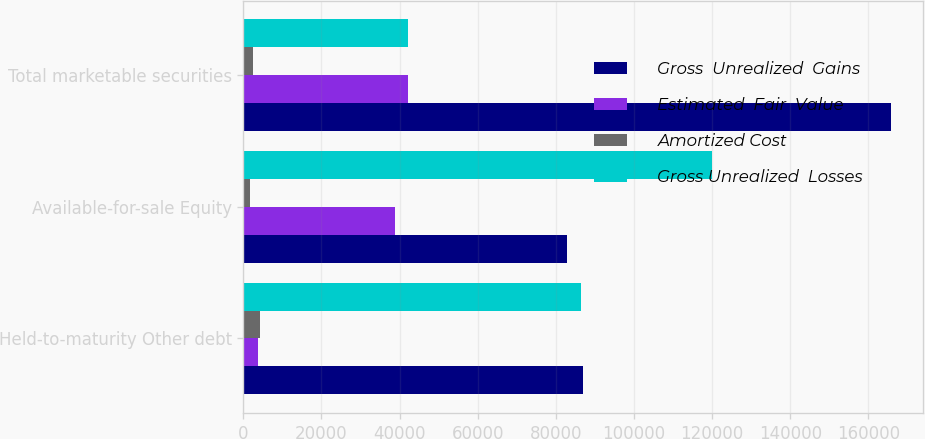Convert chart. <chart><loc_0><loc_0><loc_500><loc_500><stacked_bar_chart><ecel><fcel>Held-to-maturity Other debt<fcel>Available-for-sale Equity<fcel>Total marketable securities<nl><fcel>Gross  Unrealized  Gains<fcel>86952<fcel>82910<fcel>165716<nl><fcel>Estimated  Fair  Value<fcel>3747<fcel>38718<fcel>42169<nl><fcel>Amortized Cost<fcel>4284<fcel>1775<fcel>2414<nl><fcel>Gross Unrealized  Losses<fcel>86415<fcel>119853<fcel>42169<nl></chart> 